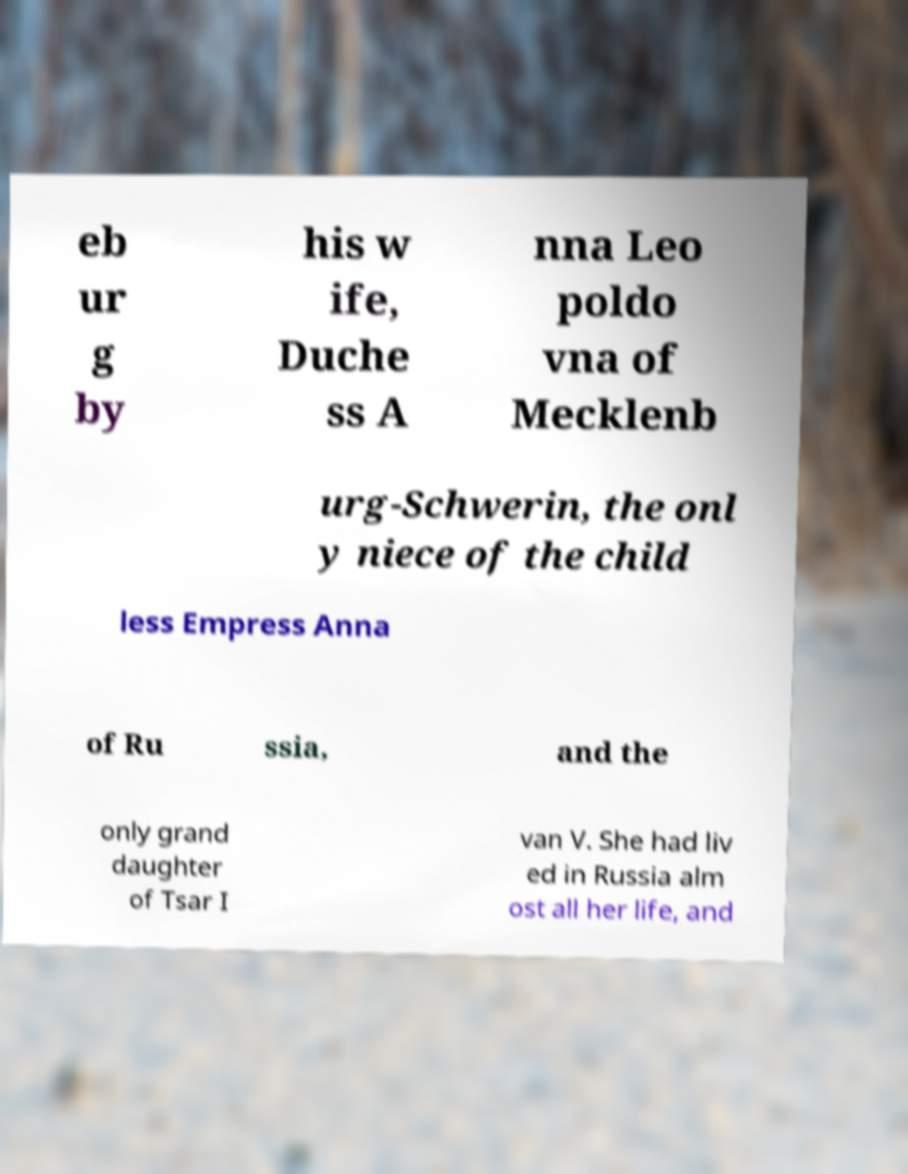I need the written content from this picture converted into text. Can you do that? eb ur g by his w ife, Duche ss A nna Leo poldo vna of Mecklenb urg-Schwerin, the onl y niece of the child less Empress Anna of Ru ssia, and the only grand daughter of Tsar I van V. She had liv ed in Russia alm ost all her life, and 